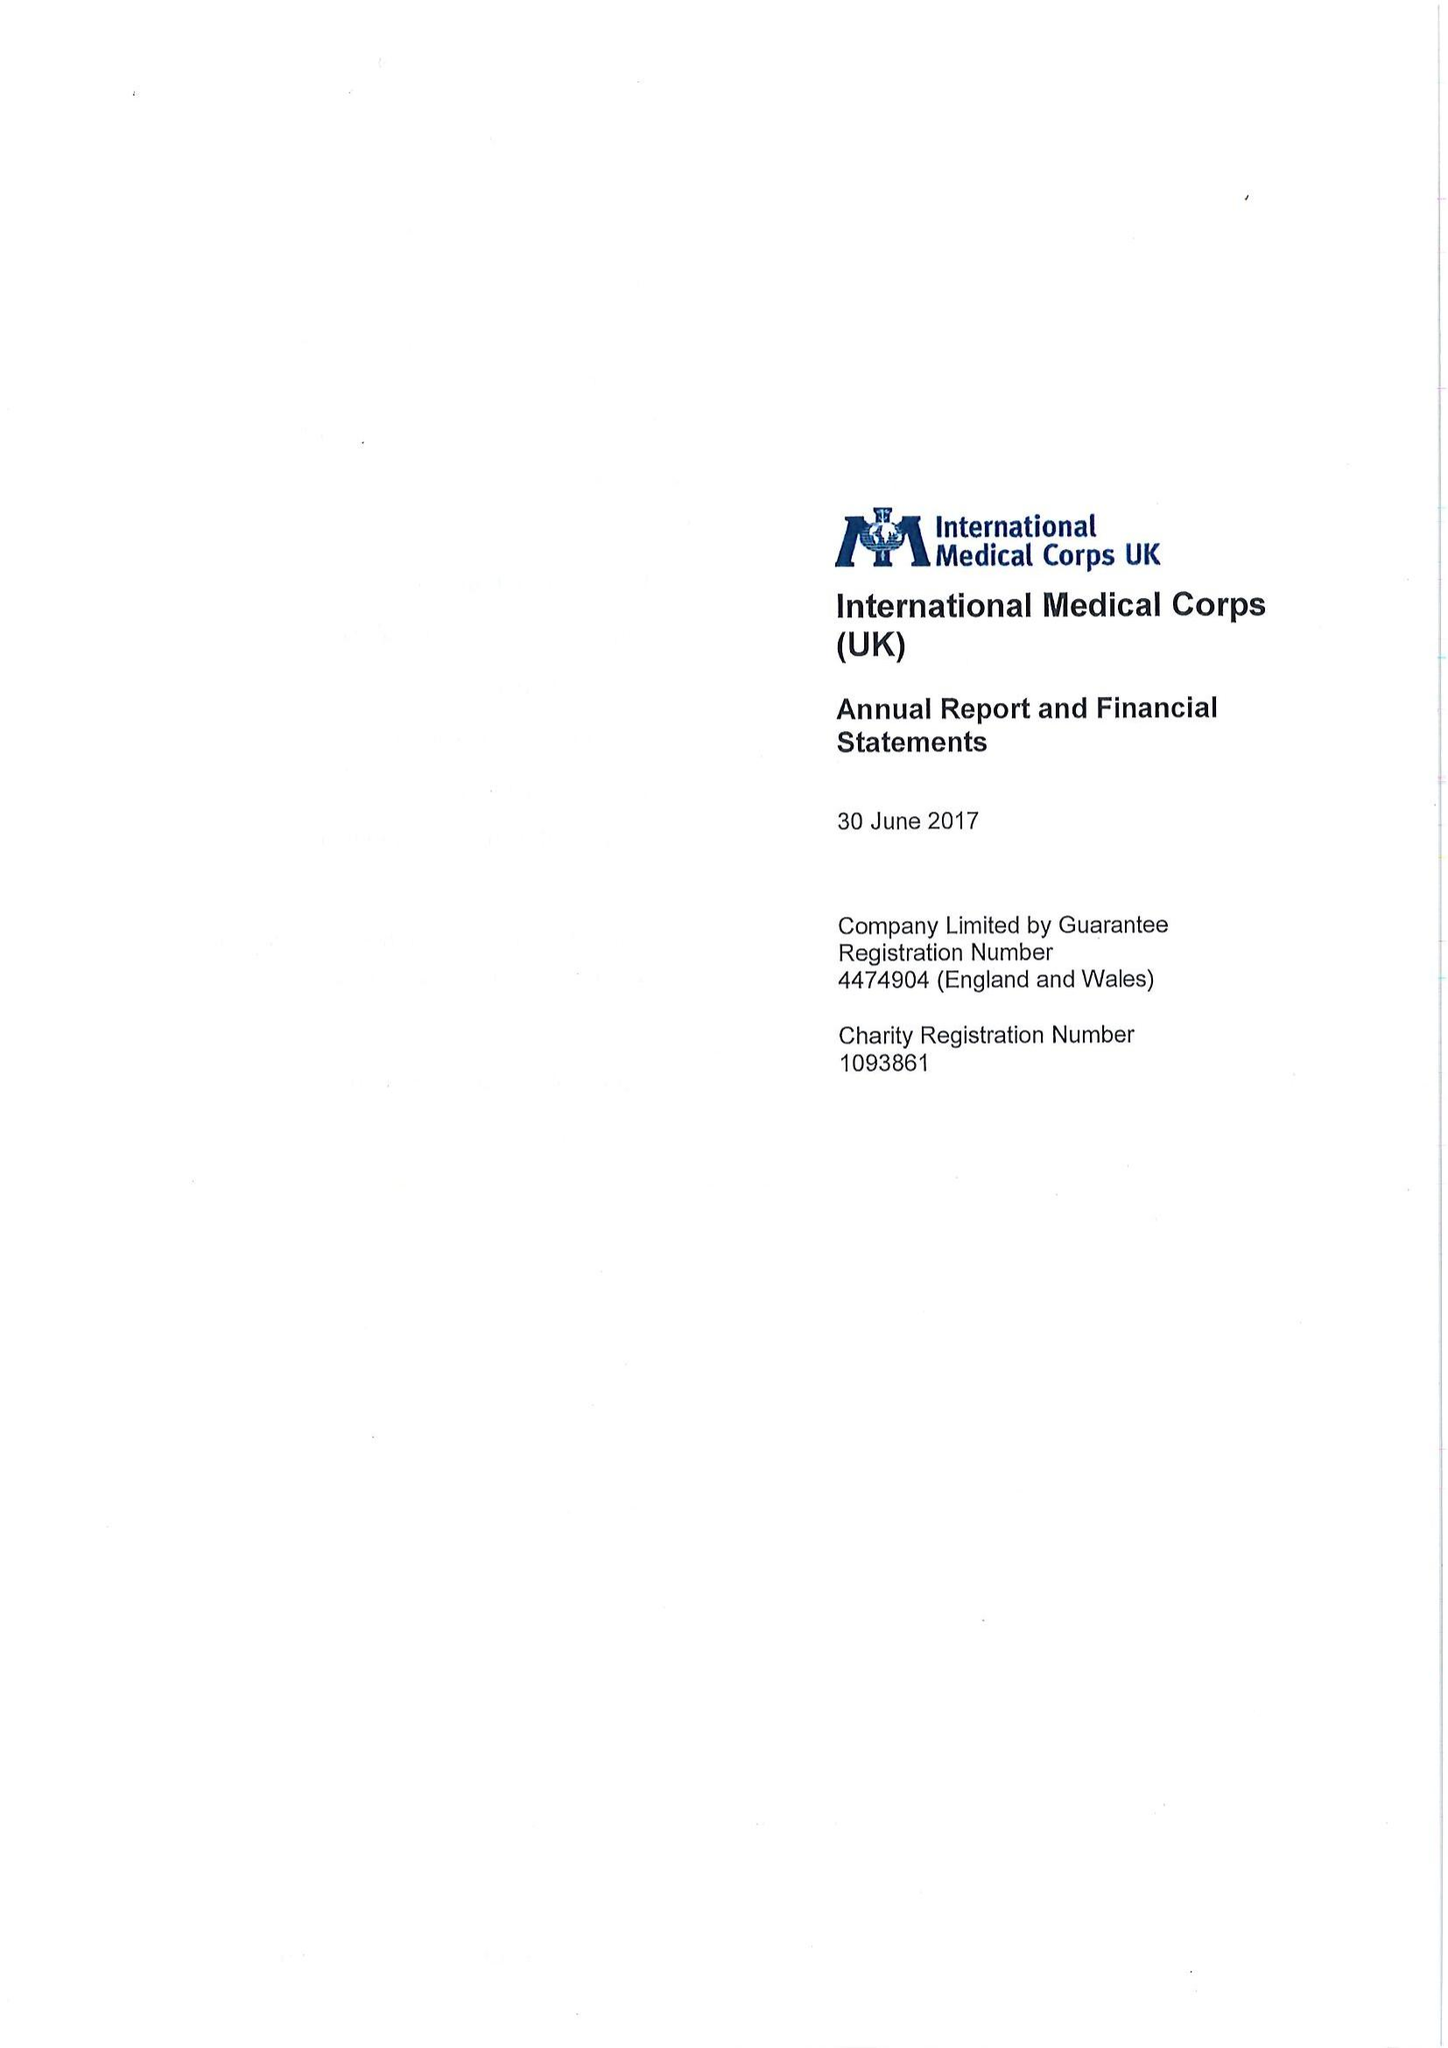What is the value for the charity_name?
Answer the question using a single word or phrase. International Medical Corps (Uk) 